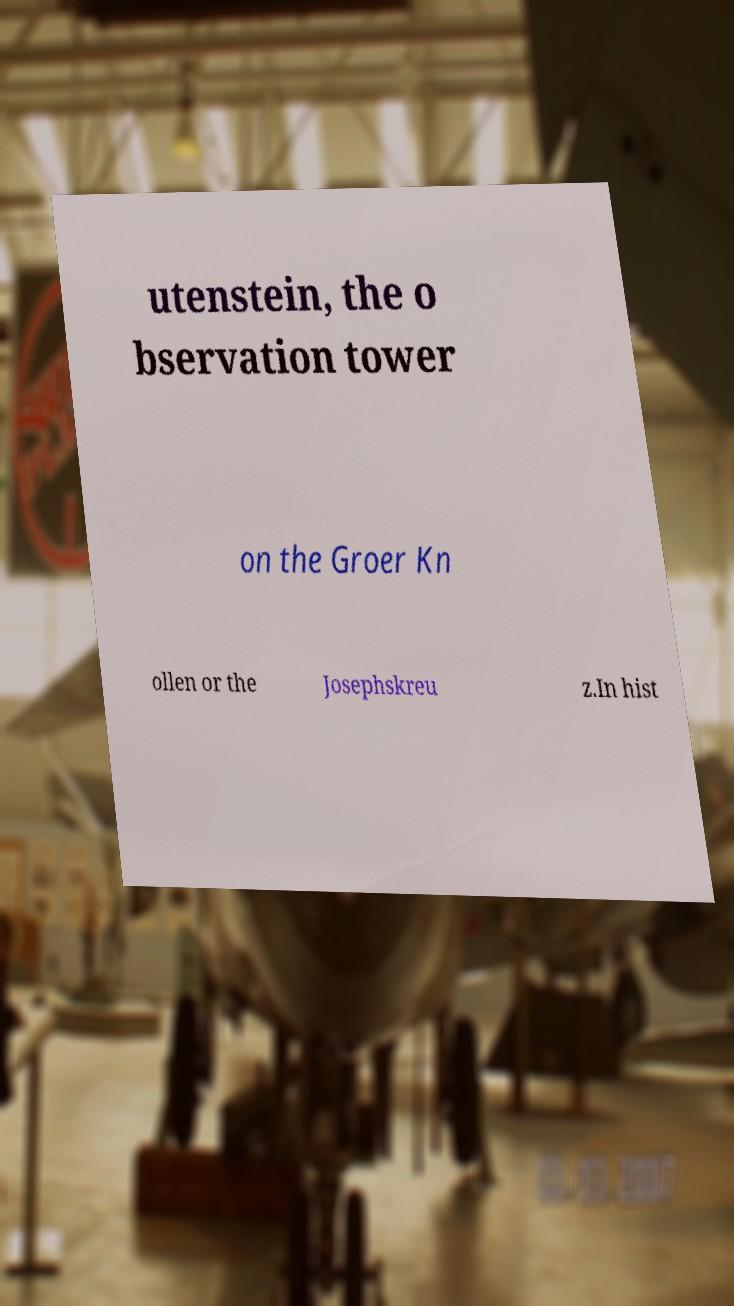Please read and relay the text visible in this image. What does it say? utenstein, the o bservation tower on the Groer Kn ollen or the Josephskreu z.In hist 